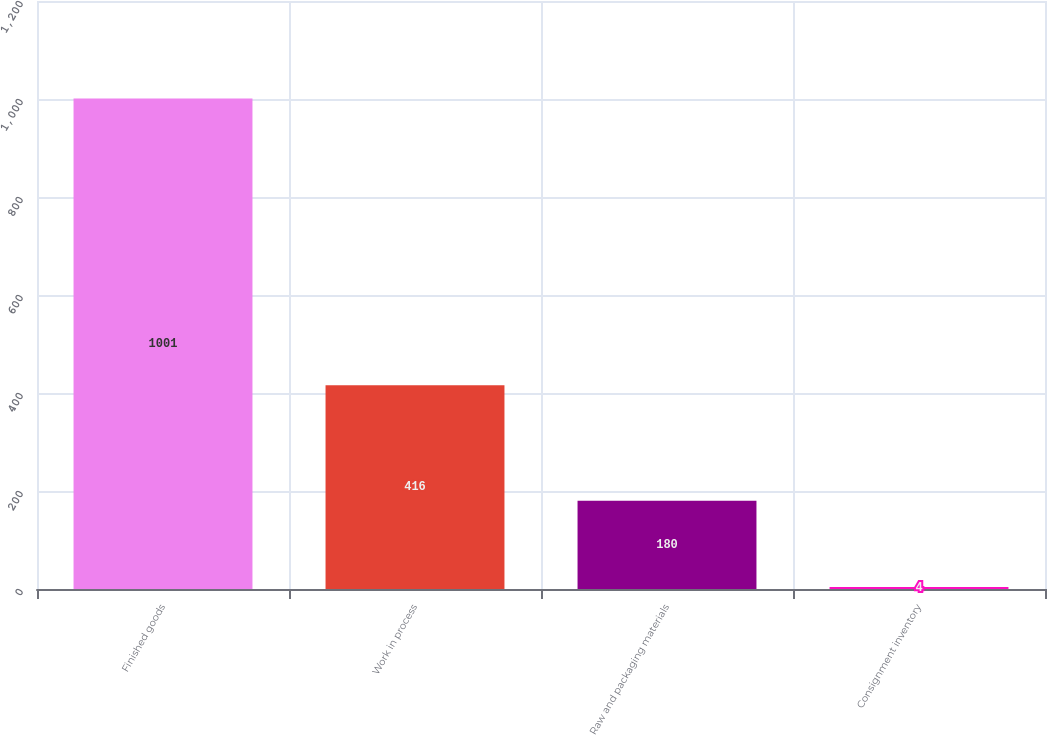Convert chart. <chart><loc_0><loc_0><loc_500><loc_500><bar_chart><fcel>Finished goods<fcel>Work in process<fcel>Raw and packaging materials<fcel>Consignment inventory<nl><fcel>1001<fcel>416<fcel>180<fcel>4<nl></chart> 